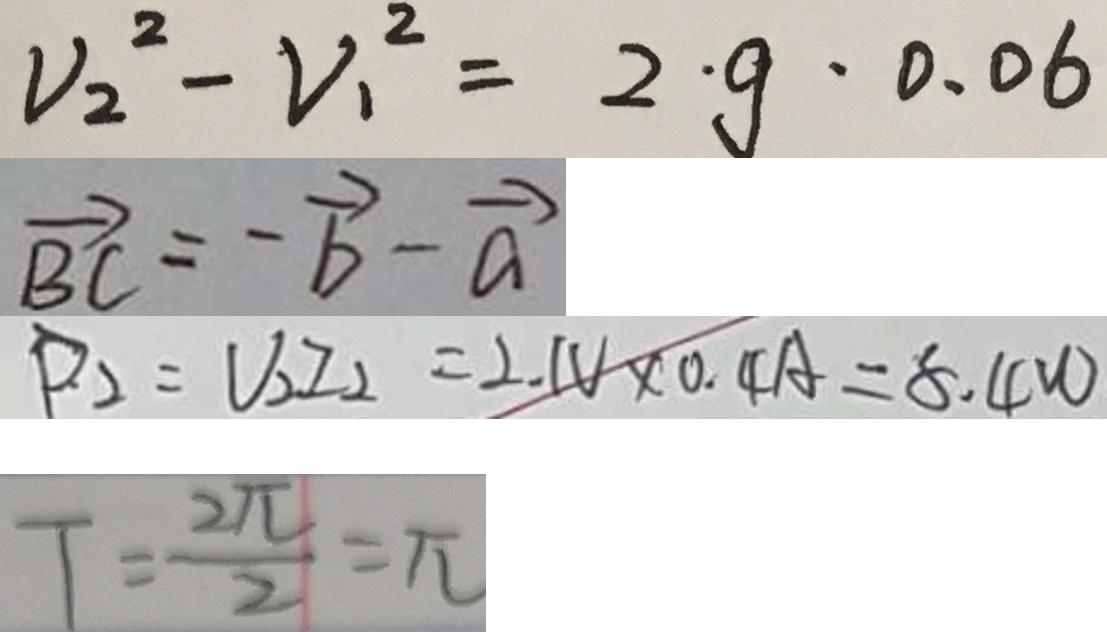Convert formula to latex. <formula><loc_0><loc_0><loc_500><loc_500>V _ { 2 } ^ { 2 } - V _ { 1 } ^ { 2 } = 2 \cdot g \cdot 0 . 0 6 
 \overrightarrow { B C } = - \overrightarrow { b } - \overrightarrow { a } 
 D _ { 2 } = V _ { 2 } I _ { 2 } = 2 . 1 V \times 0 . 4 A = 8 . 4 W 
 T = \frac { 2 \pi } { 2 } = \pi</formula> 